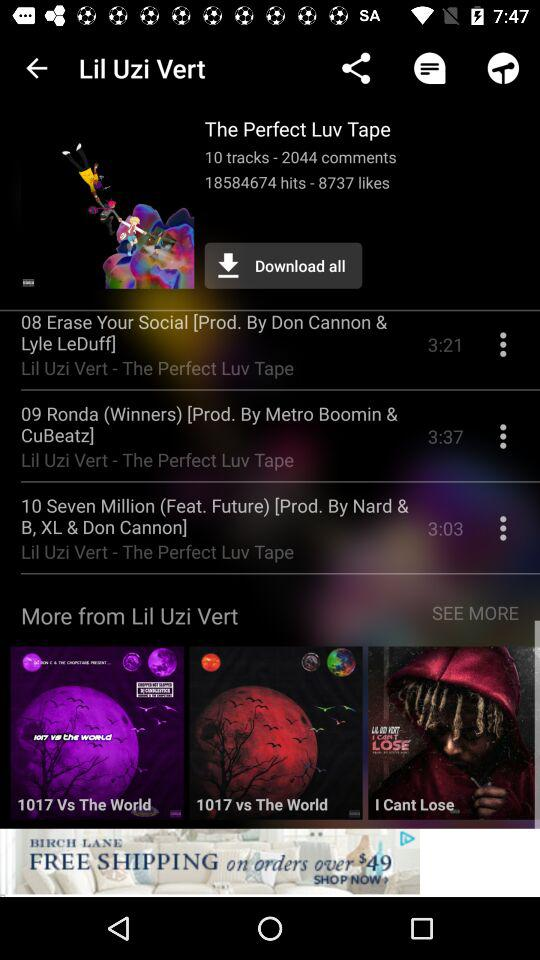What is the duration of "08 Erase Your Social"? The duration of "08 Erase Your Social" is 3 minutes and 21 seconds. 